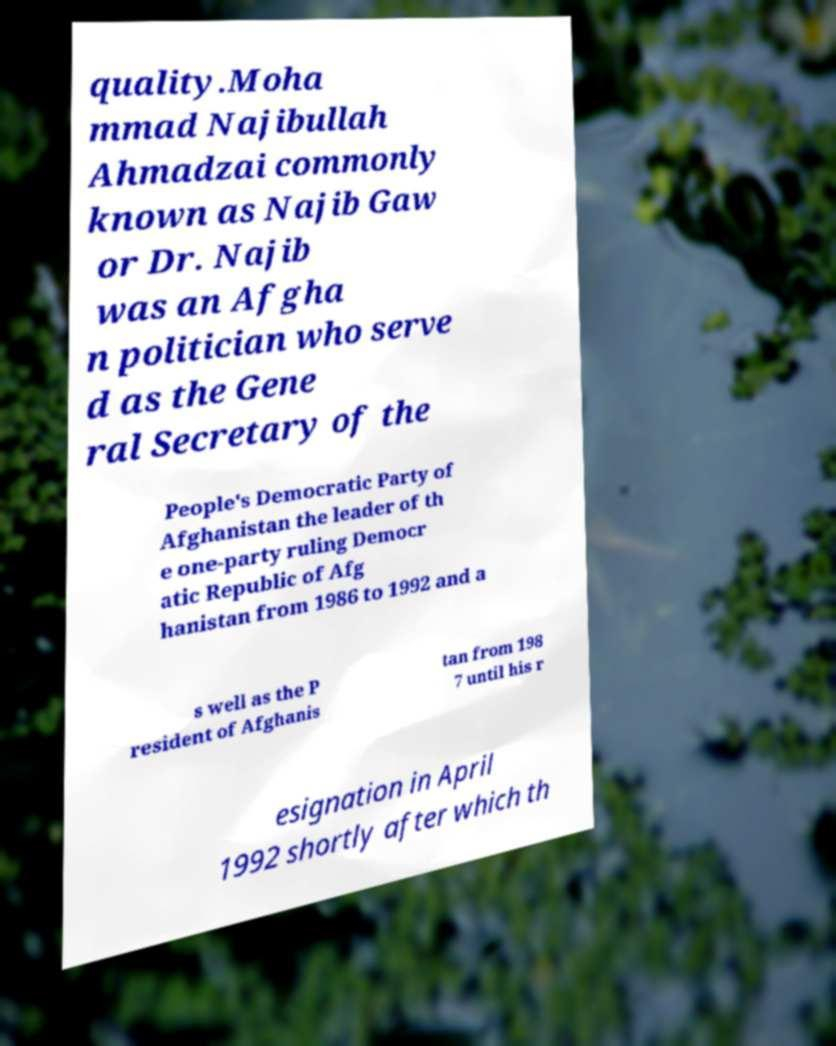I need the written content from this picture converted into text. Can you do that? quality.Moha mmad Najibullah Ahmadzai commonly known as Najib Gaw or Dr. Najib was an Afgha n politician who serve d as the Gene ral Secretary of the People's Democratic Party of Afghanistan the leader of th e one-party ruling Democr atic Republic of Afg hanistan from 1986 to 1992 and a s well as the P resident of Afghanis tan from 198 7 until his r esignation in April 1992 shortly after which th 